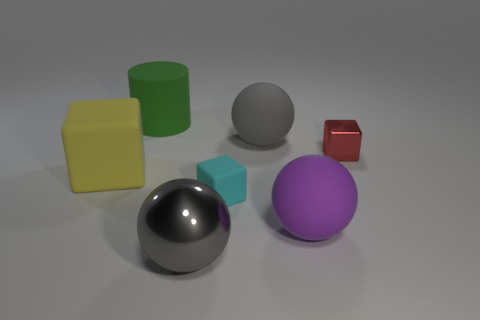How many big purple objects have the same shape as the cyan object?
Your answer should be compact. 0. What is the material of the other large ball that is the same color as the metal ball?
Make the answer very short. Rubber. Are the cyan thing and the green cylinder made of the same material?
Give a very brief answer. Yes. How many big balls are in front of the tiny object that is to the left of the gray matte thing that is behind the large yellow matte object?
Your answer should be very brief. 2. Is there a green object that has the same material as the big purple thing?
Give a very brief answer. Yes. Are there fewer gray balls than large purple metal cylinders?
Your response must be concise. No. Is the color of the large rubber sphere behind the red block the same as the big metal ball?
Keep it short and to the point. Yes. There is a gray sphere in front of the metal thing behind the object that is left of the matte cylinder; what is it made of?
Keep it short and to the point. Metal. Are there any objects of the same color as the big metal sphere?
Give a very brief answer. Yes. Are there fewer large yellow rubber objects to the right of the small rubber block than large purple metal spheres?
Your answer should be very brief. No. 